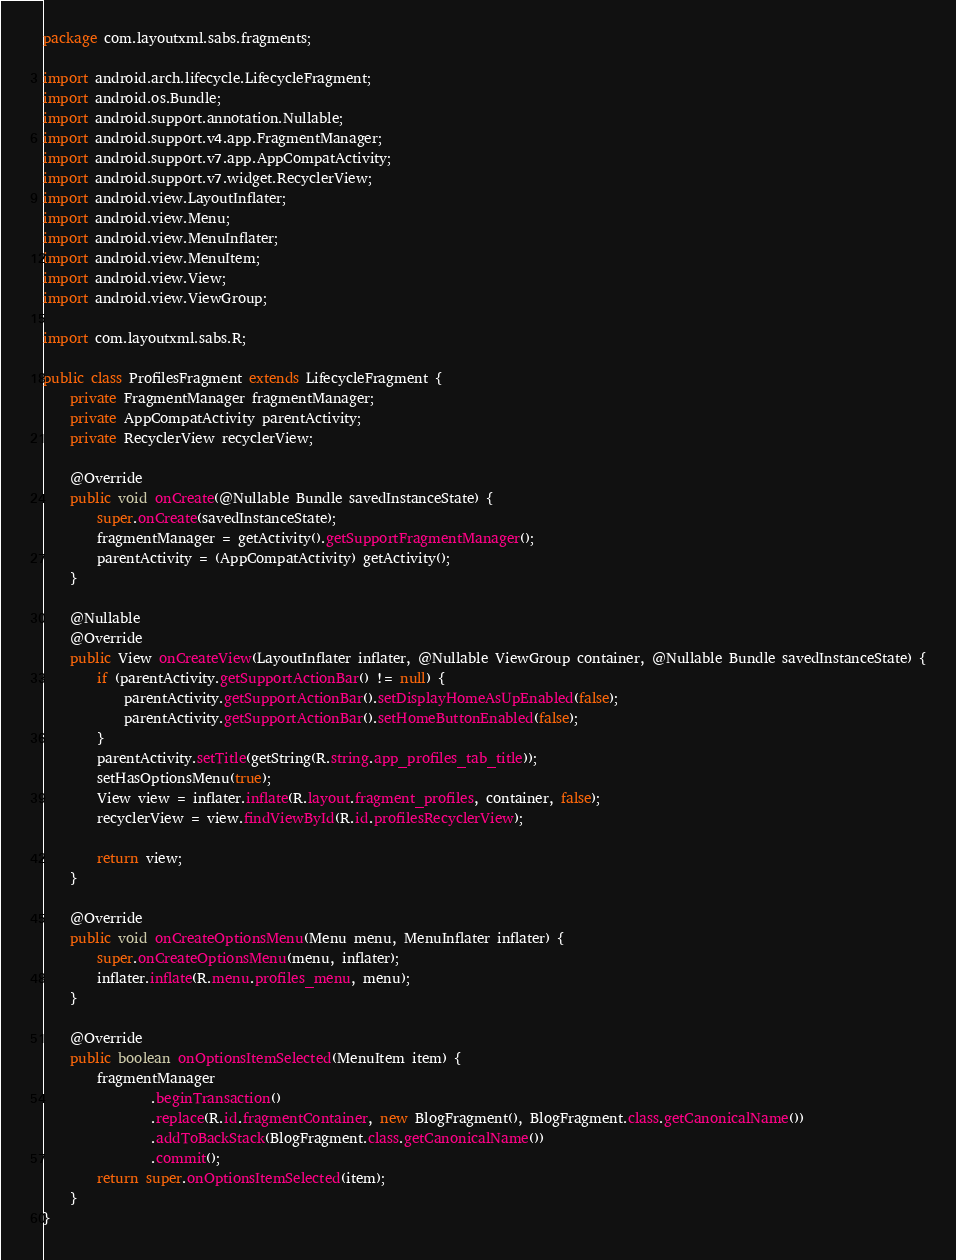<code> <loc_0><loc_0><loc_500><loc_500><_Java_>package com.layoutxml.sabs.fragments;

import android.arch.lifecycle.LifecycleFragment;
import android.os.Bundle;
import android.support.annotation.Nullable;
import android.support.v4.app.FragmentManager;
import android.support.v7.app.AppCompatActivity;
import android.support.v7.widget.RecyclerView;
import android.view.LayoutInflater;
import android.view.Menu;
import android.view.MenuInflater;
import android.view.MenuItem;
import android.view.View;
import android.view.ViewGroup;

import com.layoutxml.sabs.R;

public class ProfilesFragment extends LifecycleFragment {
    private FragmentManager fragmentManager;
    private AppCompatActivity parentActivity;
    private RecyclerView recyclerView;

    @Override
    public void onCreate(@Nullable Bundle savedInstanceState) {
        super.onCreate(savedInstanceState);
        fragmentManager = getActivity().getSupportFragmentManager();
        parentActivity = (AppCompatActivity) getActivity();
    }

    @Nullable
    @Override
    public View onCreateView(LayoutInflater inflater, @Nullable ViewGroup container, @Nullable Bundle savedInstanceState) {
        if (parentActivity.getSupportActionBar() != null) {
            parentActivity.getSupportActionBar().setDisplayHomeAsUpEnabled(false);
            parentActivity.getSupportActionBar().setHomeButtonEnabled(false);
        }
        parentActivity.setTitle(getString(R.string.app_profiles_tab_title));
        setHasOptionsMenu(true);
        View view = inflater.inflate(R.layout.fragment_profiles, container, false);
        recyclerView = view.findViewById(R.id.profilesRecyclerView);

        return view;
    }

    @Override
    public void onCreateOptionsMenu(Menu menu, MenuInflater inflater) {
        super.onCreateOptionsMenu(menu, inflater);
        inflater.inflate(R.menu.profiles_menu, menu);
    }

    @Override
    public boolean onOptionsItemSelected(MenuItem item) {
        fragmentManager
                .beginTransaction()
                .replace(R.id.fragmentContainer, new BlogFragment(), BlogFragment.class.getCanonicalName())
                .addToBackStack(BlogFragment.class.getCanonicalName())
                .commit();
        return super.onOptionsItemSelected(item);
    }
}
</code> 